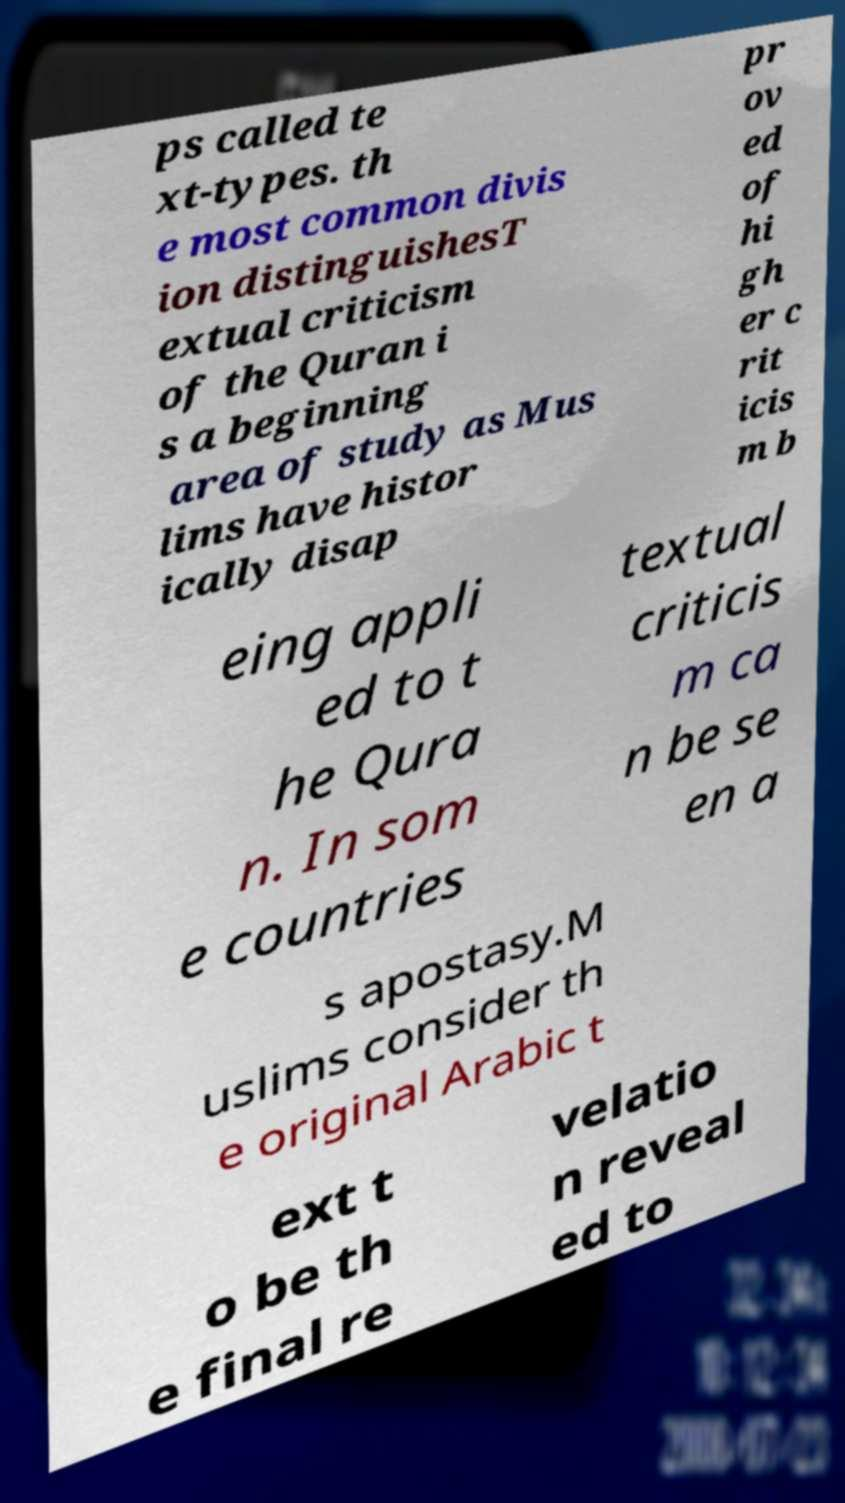Can you read and provide the text displayed in the image?This photo seems to have some interesting text. Can you extract and type it out for me? ps called te xt-types. th e most common divis ion distinguishesT extual criticism of the Quran i s a beginning area of study as Mus lims have histor ically disap pr ov ed of hi gh er c rit icis m b eing appli ed to t he Qura n. In som e countries textual criticis m ca n be se en a s apostasy.M uslims consider th e original Arabic t ext t o be th e final re velatio n reveal ed to 